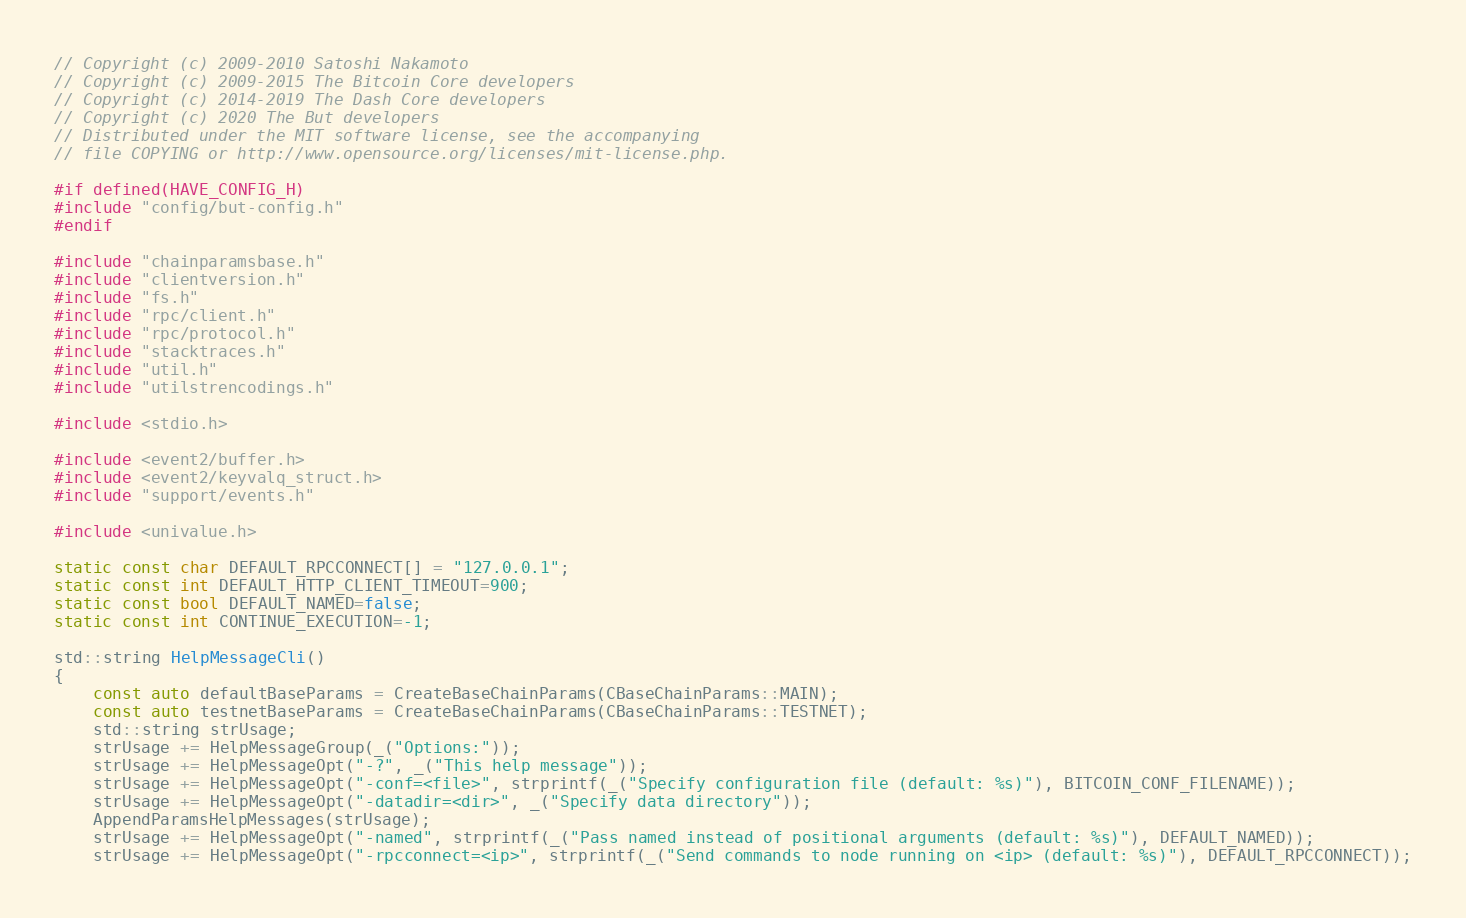Convert code to text. <code><loc_0><loc_0><loc_500><loc_500><_C++_>// Copyright (c) 2009-2010 Satoshi Nakamoto
// Copyright (c) 2009-2015 The Bitcoin Core developers
// Copyright (c) 2014-2019 The Dash Core developers
// Copyright (c) 2020 The But developers
// Distributed under the MIT software license, see the accompanying
// file COPYING or http://www.opensource.org/licenses/mit-license.php.

#if defined(HAVE_CONFIG_H)
#include "config/but-config.h"
#endif

#include "chainparamsbase.h"
#include "clientversion.h"
#include "fs.h"
#include "rpc/client.h"
#include "rpc/protocol.h"
#include "stacktraces.h"
#include "util.h"
#include "utilstrencodings.h"

#include <stdio.h>

#include <event2/buffer.h>
#include <event2/keyvalq_struct.h>
#include "support/events.h"

#include <univalue.h>

static const char DEFAULT_RPCCONNECT[] = "127.0.0.1";
static const int DEFAULT_HTTP_CLIENT_TIMEOUT=900;
static const bool DEFAULT_NAMED=false;
static const int CONTINUE_EXECUTION=-1;

std::string HelpMessageCli()
{
    const auto defaultBaseParams = CreateBaseChainParams(CBaseChainParams::MAIN);
    const auto testnetBaseParams = CreateBaseChainParams(CBaseChainParams::TESTNET);
    std::string strUsage;
    strUsage += HelpMessageGroup(_("Options:"));
    strUsage += HelpMessageOpt("-?", _("This help message"));
    strUsage += HelpMessageOpt("-conf=<file>", strprintf(_("Specify configuration file (default: %s)"), BITCOIN_CONF_FILENAME));
    strUsage += HelpMessageOpt("-datadir=<dir>", _("Specify data directory"));
    AppendParamsHelpMessages(strUsage);
    strUsage += HelpMessageOpt("-named", strprintf(_("Pass named instead of positional arguments (default: %s)"), DEFAULT_NAMED));
    strUsage += HelpMessageOpt("-rpcconnect=<ip>", strprintf(_("Send commands to node running on <ip> (default: %s)"), DEFAULT_RPCCONNECT));</code> 